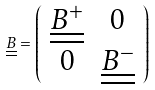Convert formula to latex. <formula><loc_0><loc_0><loc_500><loc_500>\underline { \underline { B } } = \left ( \begin{array} { c c } \underline { \underline { B ^ { + } } } & { 0 } \\ { 0 } & \underline { \underline { B ^ { - } } } \end{array} \right )</formula> 